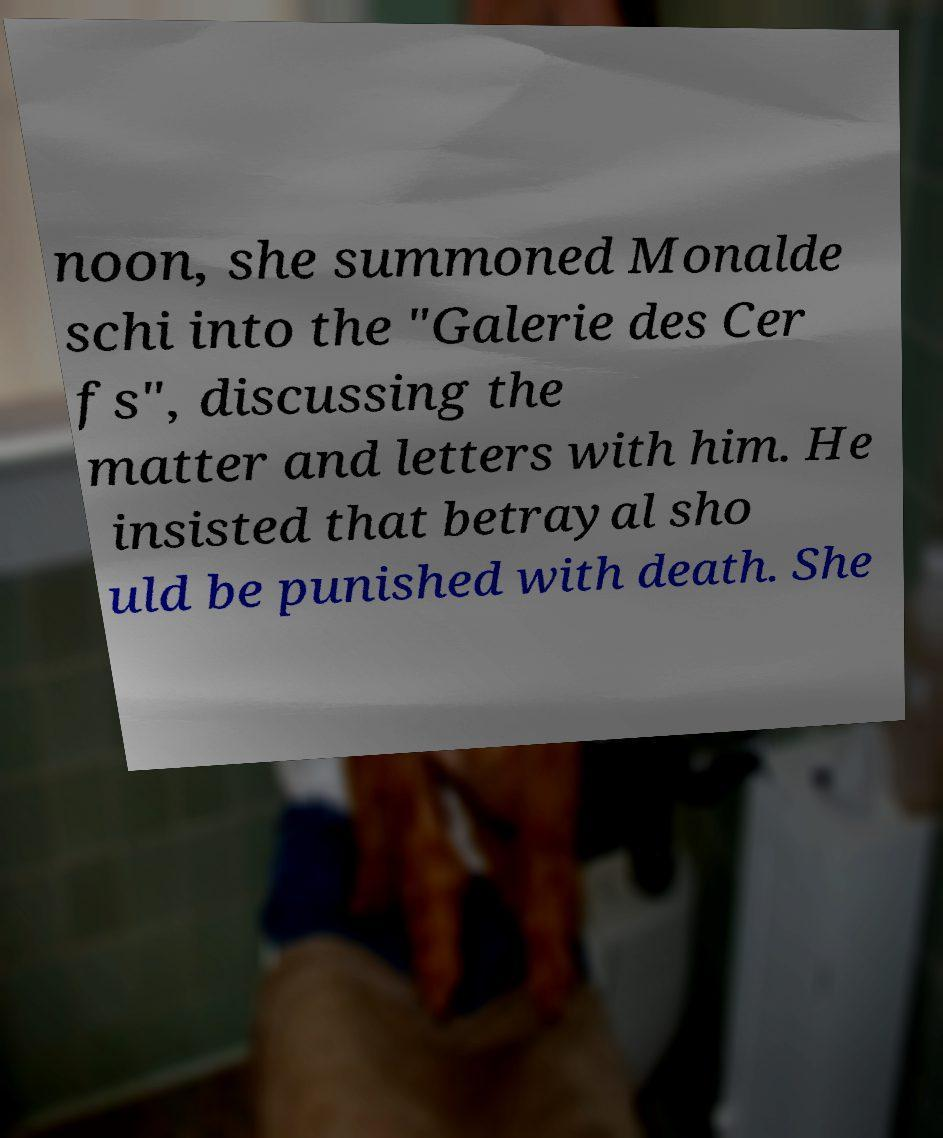Please identify and transcribe the text found in this image. noon, she summoned Monalde schi into the "Galerie des Cer fs", discussing the matter and letters with him. He insisted that betrayal sho uld be punished with death. She 